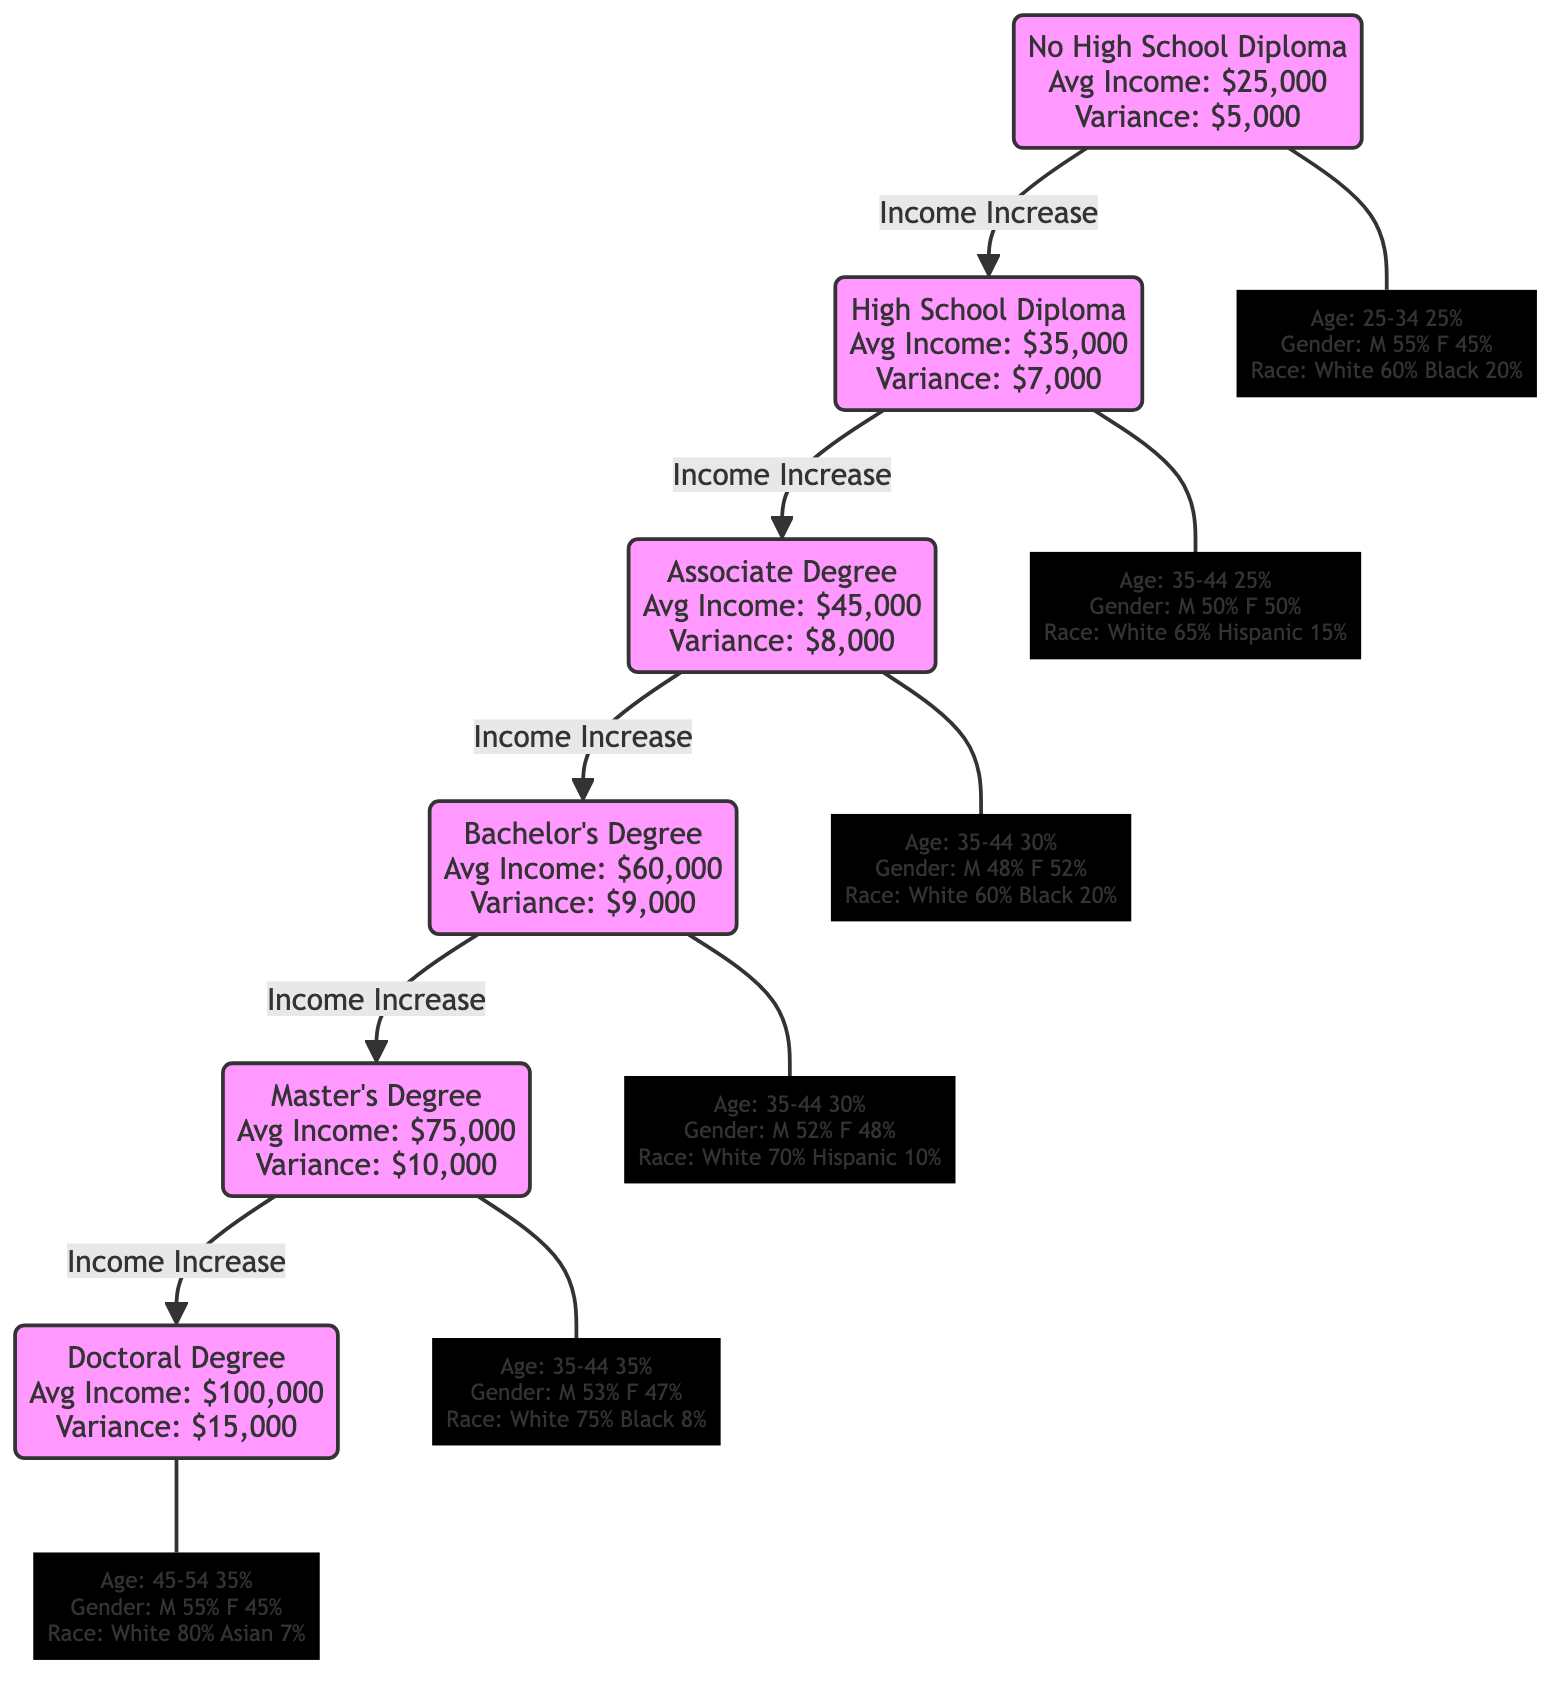What is the average income for someone with a Bachelor's Degree? The diagram states that the average income for a Bachelor's Degree is shown in the block labeled "Bachelor's Degree" and is presented as $60,000.
Answer: $60,000 What is the income variance for those with a Master's Degree? The variance for a Master's Degree is explicitly stated in its block as $10,000.
Answer: $10,000 How many age groups are represented in the demographic data for those with an Associate Degree? By examining the demographic section of the Associate Degree block, we see there are six age groups listed: 18-24, 25-34, 35-44, 45-54, 55-64, and 65+.
Answer: 6 Which education level shows the highest average income? By comparing the average incomes from each education block presented in the diagram, it is clear the Doctoral Degree displays the highest average income of $100,000.
Answer: Doctoral Degree What percentage of individuals with a High School Diploma are female? The demographic data for the High School Diploma block indicates that females make up 50% of that population.
Answer: 50% What is the average income increase from an Associate Degree to a Bachelor's Degree? The average income for an Associate Degree is $45,000 and for a Bachelor's Degree it is $60,000. Therefore, the increase is calculated as $60,000 - $45,000, which equals $15,000.
Answer: $15,000 Which education level has the highest percentage of Black individuals? In the demographic details for the No High School Diploma block, it states that 20% of that population is Black, while higher education levels tend to show lower percentages. Thus, No High School Diploma has the highest percentage of Black individuals.
Answer: No High School Diploma What percentage of the population with a Doctoral Degree is white? The race/ethnicity demographics for the Doctoral Degree block specifies that 80% of the population is white.
Answer: 80% What block represents the most significant income variance? The diagram shows that the Doctoral Degree has the highest income variance of $15,000, indicating the most significant income variability among its holders.
Answer: Doctoral Degree 